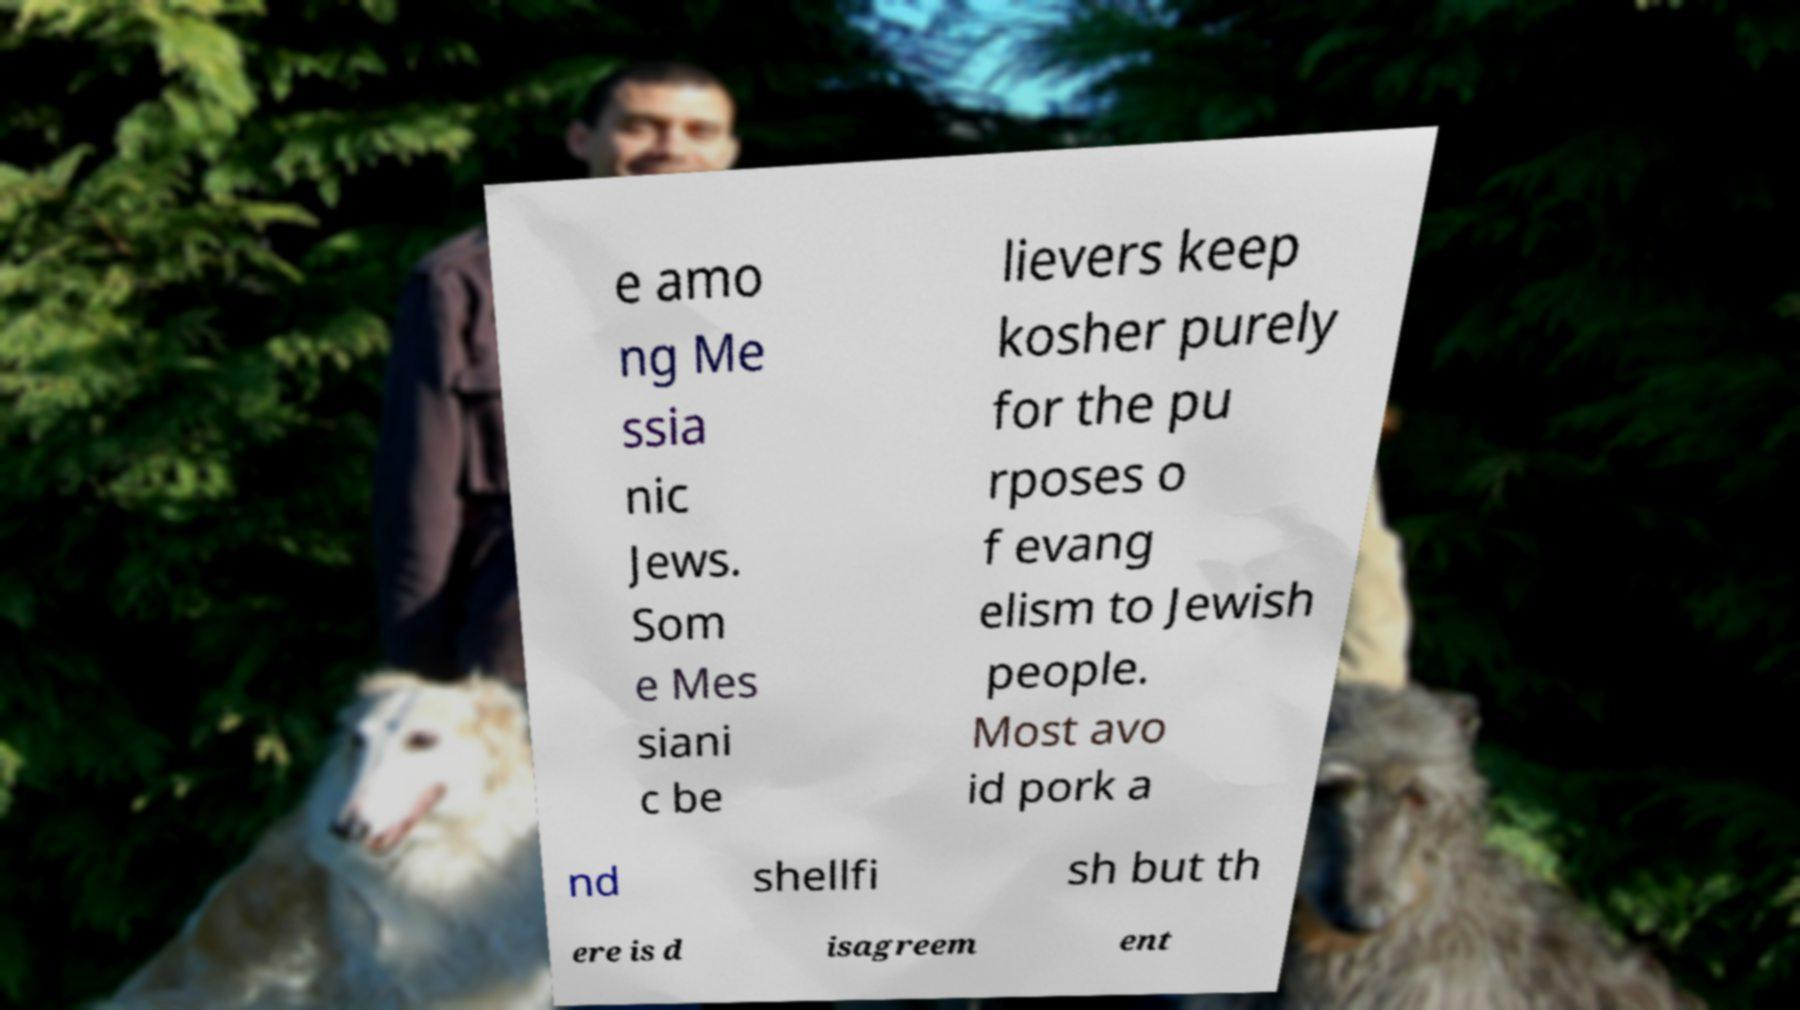Could you assist in decoding the text presented in this image and type it out clearly? e amo ng Me ssia nic Jews. Som e Mes siani c be lievers keep kosher purely for the pu rposes o f evang elism to Jewish people. Most avo id pork a nd shellfi sh but th ere is d isagreem ent 